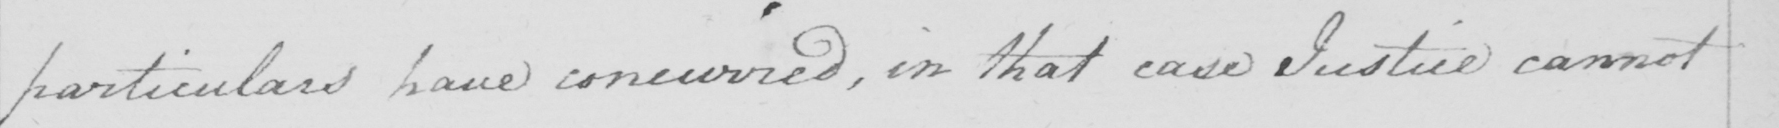Can you read and transcribe this handwriting? particulars have concurred, in that case Justice cannot 